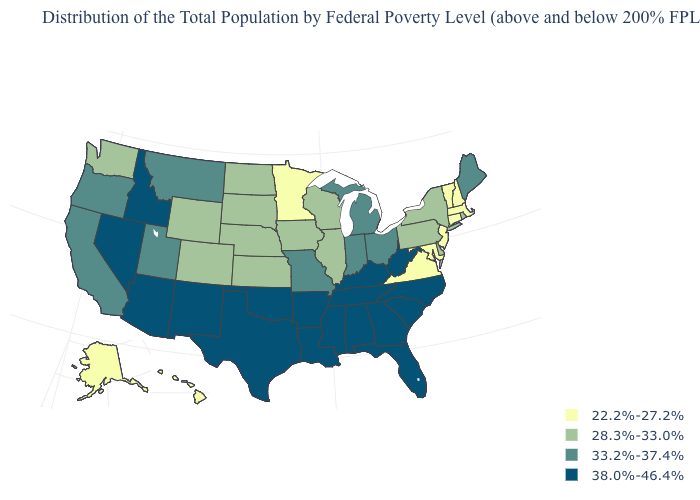What is the value of Vermont?
Short answer required. 22.2%-27.2%. Does the first symbol in the legend represent the smallest category?
Concise answer only. Yes. Name the states that have a value in the range 22.2%-27.2%?
Keep it brief. Alaska, Connecticut, Hawaii, Maryland, Massachusetts, Minnesota, New Hampshire, New Jersey, Vermont, Virginia. What is the highest value in states that border New Jersey?
Give a very brief answer. 28.3%-33.0%. Name the states that have a value in the range 33.2%-37.4%?
Answer briefly. California, Indiana, Maine, Michigan, Missouri, Montana, Ohio, Oregon, Utah. Does Massachusetts have the lowest value in the Northeast?
Short answer required. Yes. How many symbols are there in the legend?
Short answer required. 4. Does Nebraska have the lowest value in the USA?
Keep it brief. No. Which states have the highest value in the USA?
Concise answer only. Alabama, Arizona, Arkansas, Florida, Georgia, Idaho, Kentucky, Louisiana, Mississippi, Nevada, New Mexico, North Carolina, Oklahoma, South Carolina, Tennessee, Texas, West Virginia. Which states have the lowest value in the USA?
Answer briefly. Alaska, Connecticut, Hawaii, Maryland, Massachusetts, Minnesota, New Hampshire, New Jersey, Vermont, Virginia. Name the states that have a value in the range 22.2%-27.2%?
Concise answer only. Alaska, Connecticut, Hawaii, Maryland, Massachusetts, Minnesota, New Hampshire, New Jersey, Vermont, Virginia. Among the states that border Wyoming , does South Dakota have the highest value?
Keep it brief. No. Name the states that have a value in the range 33.2%-37.4%?
Be succinct. California, Indiana, Maine, Michigan, Missouri, Montana, Ohio, Oregon, Utah. What is the lowest value in states that border Delaware?
Answer briefly. 22.2%-27.2%. Name the states that have a value in the range 33.2%-37.4%?
Write a very short answer. California, Indiana, Maine, Michigan, Missouri, Montana, Ohio, Oregon, Utah. 